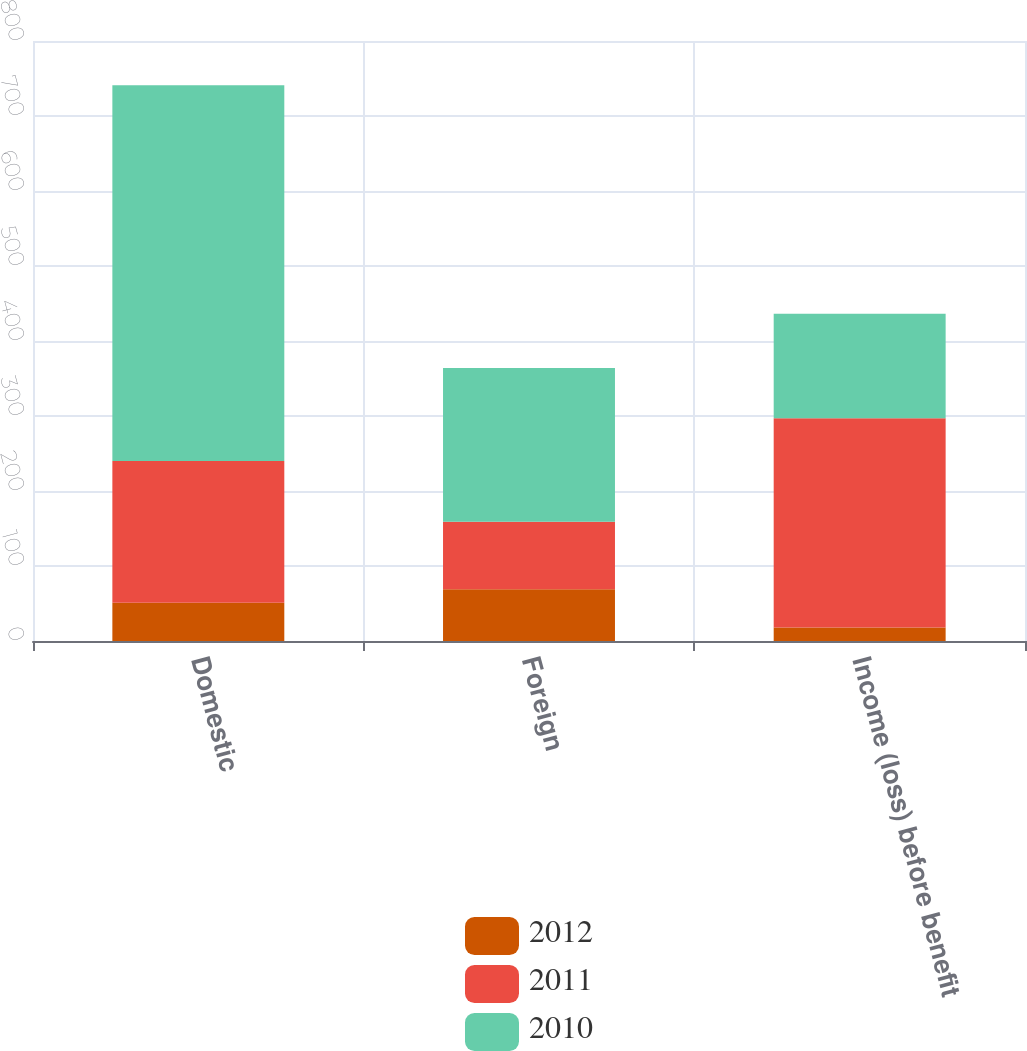Convert chart to OTSL. <chart><loc_0><loc_0><loc_500><loc_500><stacked_bar_chart><ecel><fcel>Domestic<fcel>Foreign<fcel>Income (loss) before benefit<nl><fcel>2012<fcel>51<fcel>69<fcel>18<nl><fcel>2011<fcel>189<fcel>90<fcel>279<nl><fcel>2010<fcel>501<fcel>205<fcel>139.5<nl></chart> 